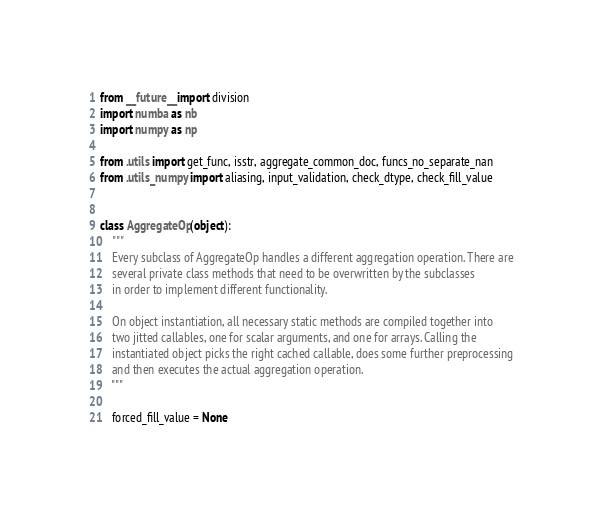<code> <loc_0><loc_0><loc_500><loc_500><_Python_>from __future__ import division
import numba as nb
import numpy as np

from .utils import get_func, isstr, aggregate_common_doc, funcs_no_separate_nan
from .utils_numpy import aliasing, input_validation, check_dtype, check_fill_value


class AggregateOp(object):
    """
    Every subclass of AggregateOp handles a different aggregation operation. There are
    several private class methods that need to be overwritten by the subclasses
    in order to implement different functionality.

    On object instantiation, all necessary static methods are compiled together into
    two jitted callables, one for scalar arguments, and one for arrays. Calling the
    instantiated object picks the right cached callable, does some further preprocessing
    and then executes the actual aggregation operation.
    """

    forced_fill_value = None</code> 